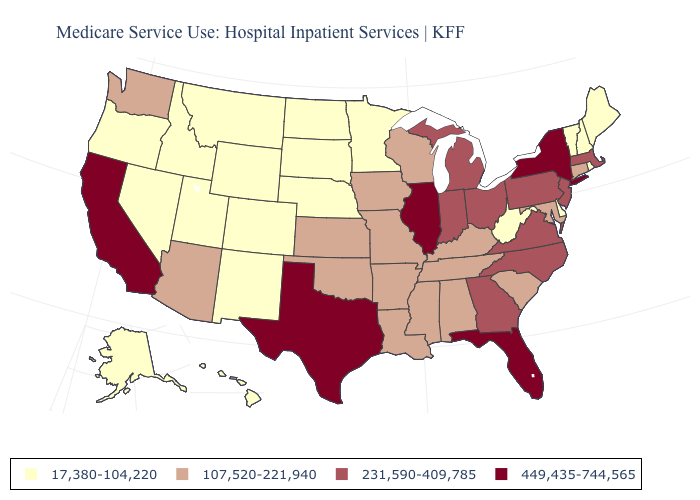Among the states that border New York , which have the highest value?
Answer briefly. Massachusetts, New Jersey, Pennsylvania. Name the states that have a value in the range 107,520-221,940?
Concise answer only. Alabama, Arizona, Arkansas, Connecticut, Iowa, Kansas, Kentucky, Louisiana, Maryland, Mississippi, Missouri, Oklahoma, South Carolina, Tennessee, Washington, Wisconsin. Does California have the highest value in the USA?
Concise answer only. Yes. What is the highest value in states that border Iowa?
Answer briefly. 449,435-744,565. What is the value of Connecticut?
Be succinct. 107,520-221,940. Which states have the lowest value in the USA?
Write a very short answer. Alaska, Colorado, Delaware, Hawaii, Idaho, Maine, Minnesota, Montana, Nebraska, Nevada, New Hampshire, New Mexico, North Dakota, Oregon, Rhode Island, South Dakota, Utah, Vermont, West Virginia, Wyoming. Name the states that have a value in the range 107,520-221,940?
Quick response, please. Alabama, Arizona, Arkansas, Connecticut, Iowa, Kansas, Kentucky, Louisiana, Maryland, Mississippi, Missouri, Oklahoma, South Carolina, Tennessee, Washington, Wisconsin. Name the states that have a value in the range 17,380-104,220?
Quick response, please. Alaska, Colorado, Delaware, Hawaii, Idaho, Maine, Minnesota, Montana, Nebraska, Nevada, New Hampshire, New Mexico, North Dakota, Oregon, Rhode Island, South Dakota, Utah, Vermont, West Virginia, Wyoming. Does Pennsylvania have a higher value than North Carolina?
Short answer required. No. What is the highest value in states that border New Mexico?
Short answer required. 449,435-744,565. Does the map have missing data?
Short answer required. No. What is the lowest value in the USA?
Quick response, please. 17,380-104,220. What is the value of Connecticut?
Write a very short answer. 107,520-221,940. Name the states that have a value in the range 17,380-104,220?
Be succinct. Alaska, Colorado, Delaware, Hawaii, Idaho, Maine, Minnesota, Montana, Nebraska, Nevada, New Hampshire, New Mexico, North Dakota, Oregon, Rhode Island, South Dakota, Utah, Vermont, West Virginia, Wyoming. Name the states that have a value in the range 231,590-409,785?
Quick response, please. Georgia, Indiana, Massachusetts, Michigan, New Jersey, North Carolina, Ohio, Pennsylvania, Virginia. 